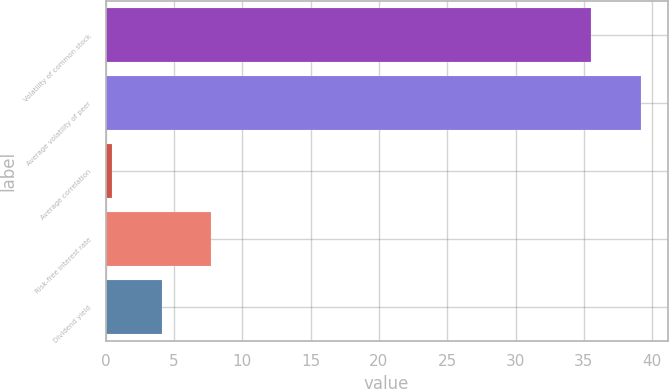Convert chart to OTSL. <chart><loc_0><loc_0><loc_500><loc_500><bar_chart><fcel>Volatility of common stock<fcel>Average volatility of peer<fcel>Average correlation<fcel>Risk-free interest rate<fcel>Dividend yield<nl><fcel>35.54<fcel>39.17<fcel>0.47<fcel>7.73<fcel>4.1<nl></chart> 